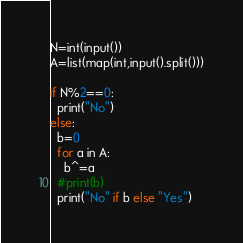Convert code to text. <code><loc_0><loc_0><loc_500><loc_500><_Python_>N=int(input())
A=list(map(int,input().split()))

if N%2==0:
  print("No")
else:
  b=0
  for a in A:
    b^=a
  #print(b)
  print("No" if b else "Yes")</code> 